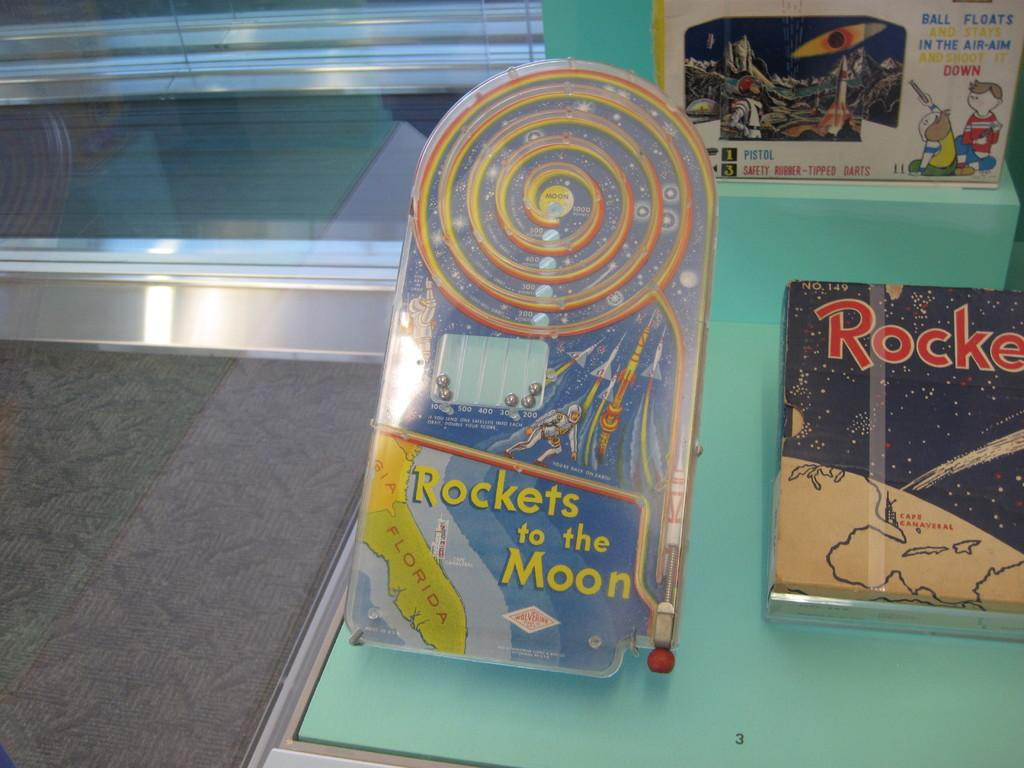<image>
Give a short and clear explanation of the subsequent image. A pinball toy is titled Rockets to the Moon. 